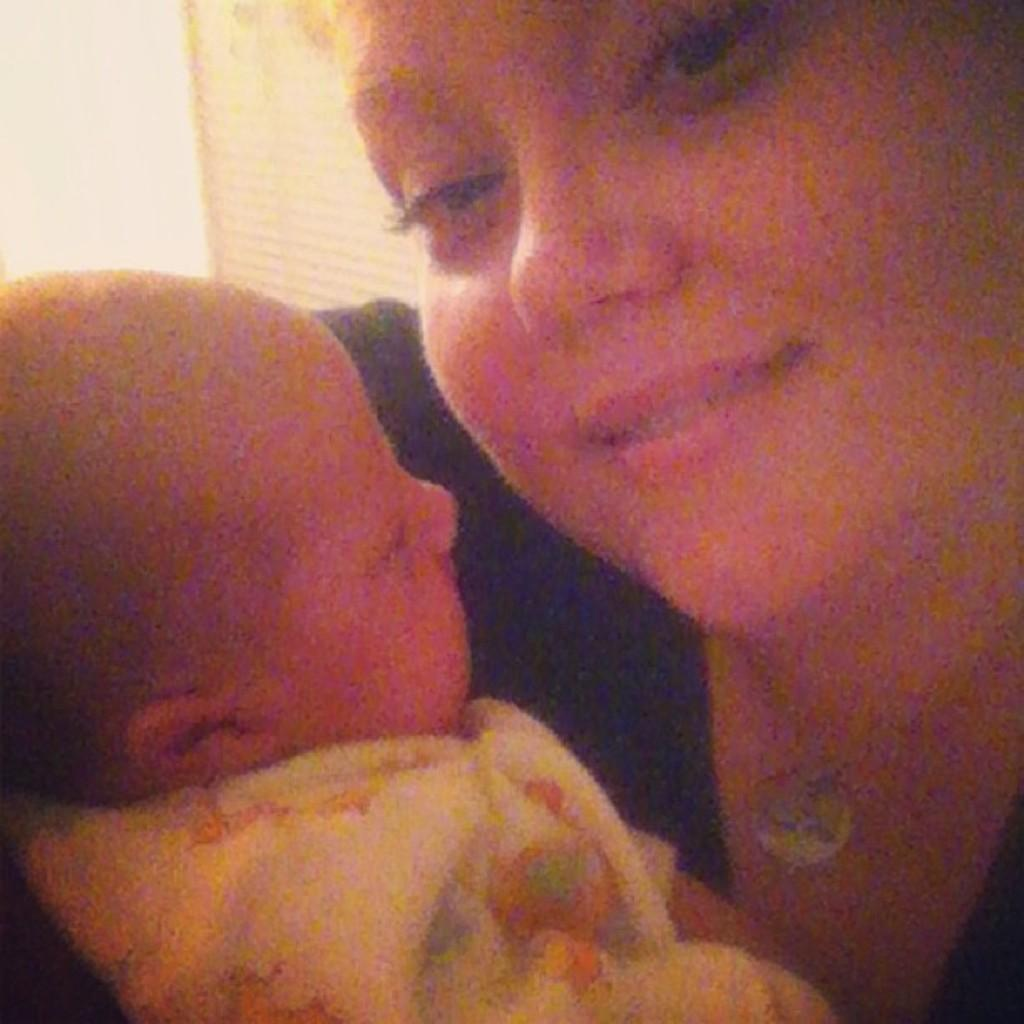Who is the main subject in the image? There is a woman in the image. What is the woman doing in the image? The woman is smiling and holding a baby. What can be seen in the background of the image? There is a wall in the background of the image. What type of hen can be seen in the image? There is no hen present in the image. What ornament is hanging on the wall in the image? There is no information provided about any ornaments hanging on the wall in the image. 